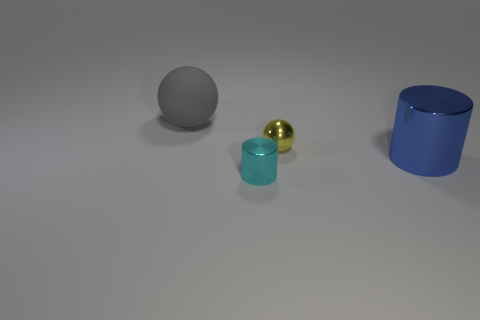Add 2 large cylinders. How many objects exist? 6 Subtract all rubber balls. Subtract all tiny cyan objects. How many objects are left? 2 Add 2 large blue metal cylinders. How many large blue metal cylinders are left? 3 Add 4 big metal cylinders. How many big metal cylinders exist? 5 Subtract 0 green cylinders. How many objects are left? 4 